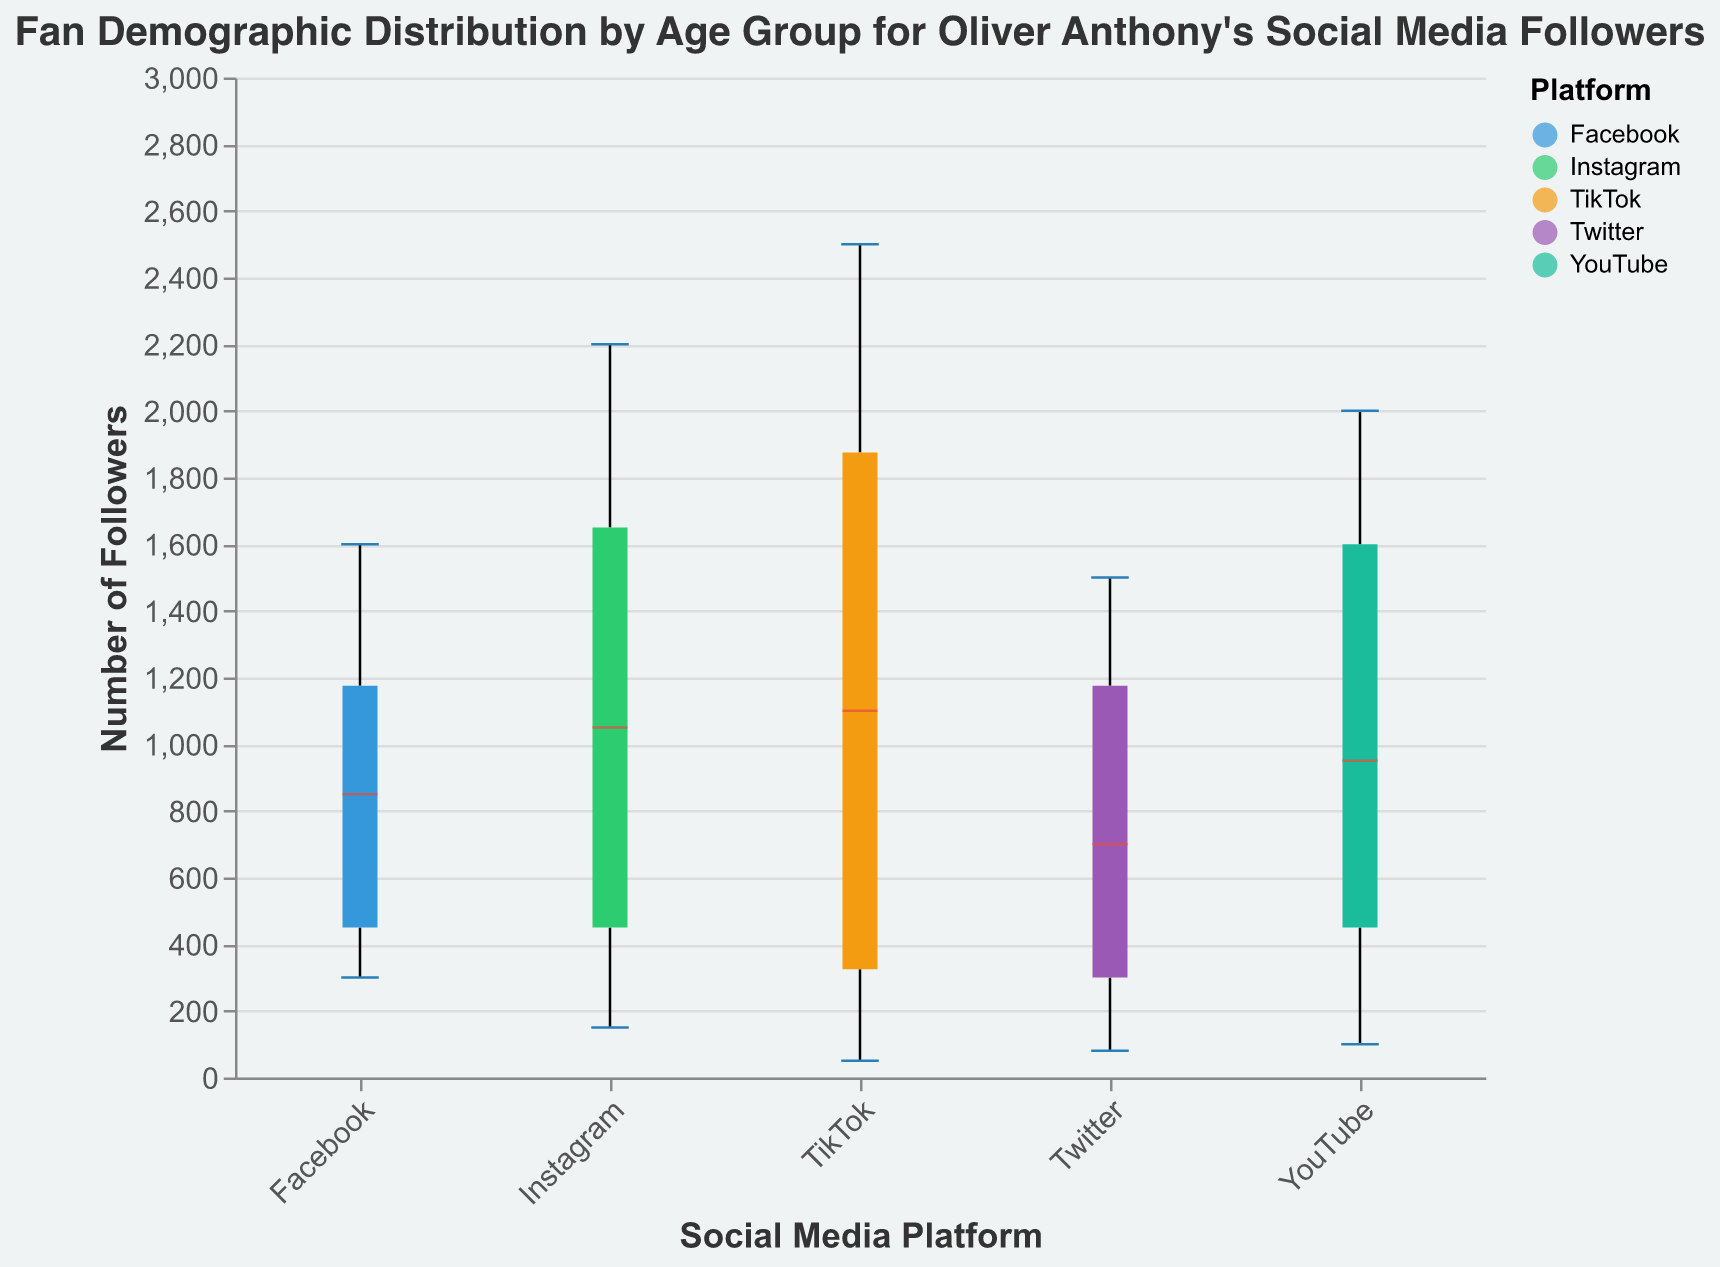What is the title of the figure? The title is typically displayed at the top of the figure. Here, it reads "Fan Demographic Distribution by Age Group for Oliver Anthony's Social Media Followers."
Answer: Fan Demographic Distribution by Age Group for Oliver Anthony's Social Media Followers Which social media platform has the highest number of followers in the 18-24 age group? By observing the box plots, the TikTok platform has the highest number of followers in the 18-24 age group, reaching 2500 followers.
Answer: TikTok What is the median number of followers on Instagram? In a box plot, the median is marked differently (e.g., with a different color line), here identified by color. The median line sits at 1200 for Instagram.
Answer: 1200 Which social media platform has the widest range of followers in the 13-17 age group? The range in a box plot is indicated by the distance between the minimum and maximum values represented by the whiskers. TikTok has the widest range, extending from 2000 to 150.
Answer: TikTok How many followers are there on Facebook in the 25-34 age group? The exact follower count for each group is listed in the data table. For Facebook, the number is 1600 followers.
Answer: 1600 Which age group has the smallest number of followers across all platforms? By examining the minimum values in the box plots for each age group, the 55+ age group has the smallest number of followers across all platforms, with lows such as 50 followers on TikTok.
Answer: 55+ What is the range of followers for the 25-34 age group on YouTube? The range is determined by the maximum and minimum values. For YouTube's 25-34 age group, it ranges from 2000 followers to 0 followers, but within the box plot, it shows from 1000 to 1900.
Answer: 1000 to 2000 Which platform shows the highest variability in followers for the 35-44 age group? Variability is indicated by the length of the box and whiskers. Here, YouTube shows high variability with followers ranging from 900 to 1800.
Answer: YouTube What is the average number of followers for the 18-24 age group across all platforms? Add the followers in the 18-24 age group across all platforms and divide by the number of platforms: (2200 + 1500 + 1200 + 2500 + 1800) / 5 = 1840.
Answer: 1840 Between Instagram and Twitter, which platform has more followers in the 13-17 age group? Compare the follower counts for the 13-17 age group on Instagram (1200) and Twitter (800).
Answer: Instagram 